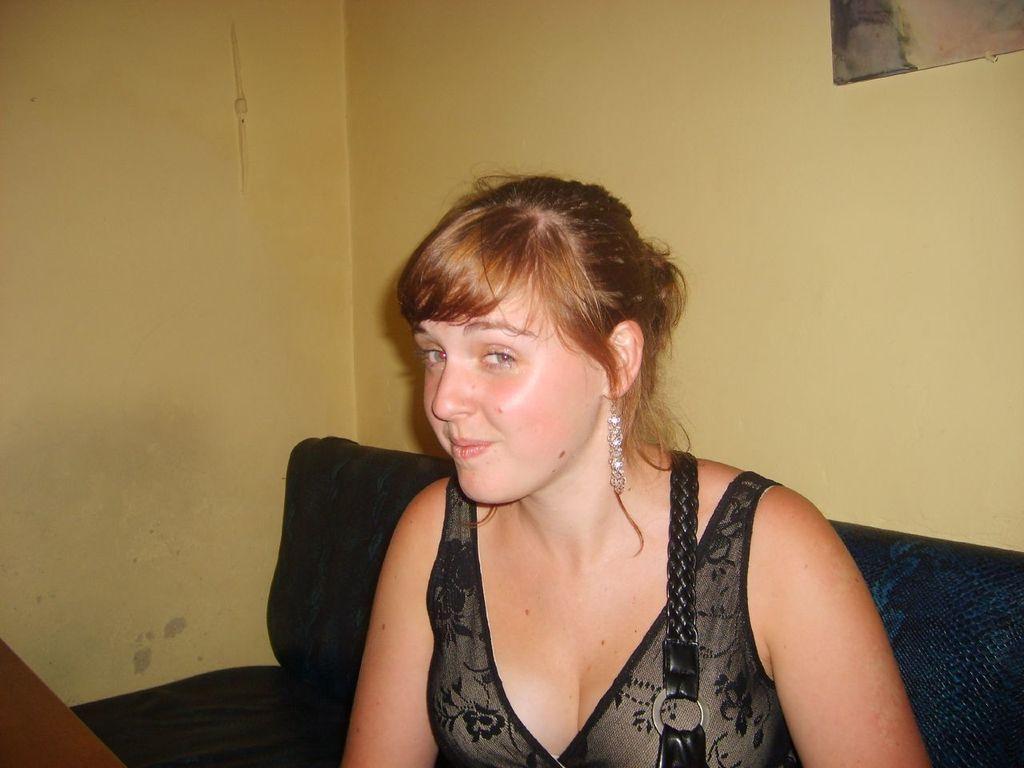Can you describe this image briefly? In this picture we can see a woman sitting on a sofa and in the background we can see a photo frame on the wall. 